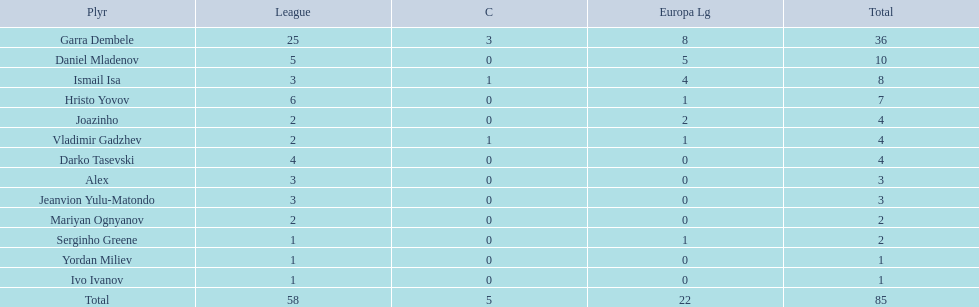What is the sum of the cup total and the europa league total? 27. 